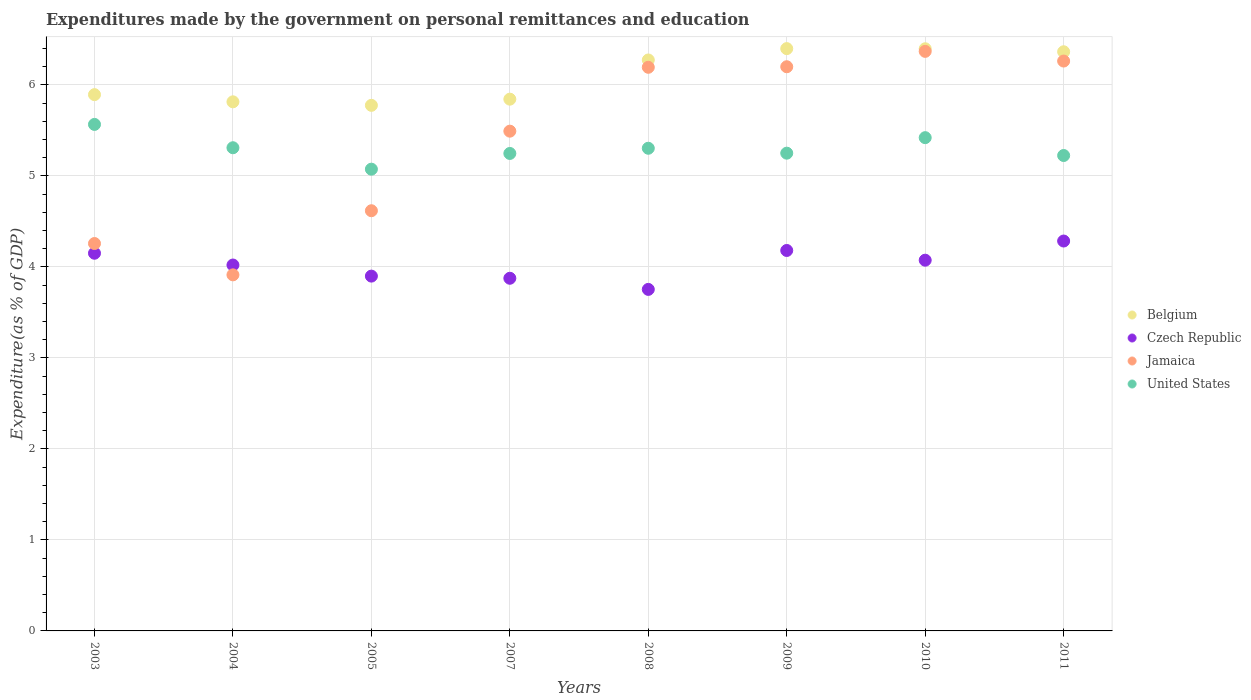How many different coloured dotlines are there?
Provide a succinct answer. 4. What is the expenditures made by the government on personal remittances and education in Belgium in 2004?
Give a very brief answer. 5.81. Across all years, what is the maximum expenditures made by the government on personal remittances and education in United States?
Give a very brief answer. 5.57. Across all years, what is the minimum expenditures made by the government on personal remittances and education in United States?
Provide a succinct answer. 5.07. In which year was the expenditures made by the government on personal remittances and education in United States minimum?
Provide a succinct answer. 2005. What is the total expenditures made by the government on personal remittances and education in Jamaica in the graph?
Offer a terse response. 43.3. What is the difference between the expenditures made by the government on personal remittances and education in Jamaica in 2009 and that in 2010?
Your answer should be very brief. -0.17. What is the difference between the expenditures made by the government on personal remittances and education in Czech Republic in 2010 and the expenditures made by the government on personal remittances and education in Jamaica in 2007?
Provide a succinct answer. -1.42. What is the average expenditures made by the government on personal remittances and education in Czech Republic per year?
Keep it short and to the point. 4.03. In the year 2010, what is the difference between the expenditures made by the government on personal remittances and education in Czech Republic and expenditures made by the government on personal remittances and education in Belgium?
Offer a terse response. -2.32. What is the ratio of the expenditures made by the government on personal remittances and education in Jamaica in 2003 to that in 2010?
Your response must be concise. 0.67. Is the difference between the expenditures made by the government on personal remittances and education in Czech Republic in 2004 and 2011 greater than the difference between the expenditures made by the government on personal remittances and education in Belgium in 2004 and 2011?
Offer a very short reply. Yes. What is the difference between the highest and the second highest expenditures made by the government on personal remittances and education in Jamaica?
Give a very brief answer. 0.11. What is the difference between the highest and the lowest expenditures made by the government on personal remittances and education in United States?
Keep it short and to the point. 0.49. In how many years, is the expenditures made by the government on personal remittances and education in Jamaica greater than the average expenditures made by the government on personal remittances and education in Jamaica taken over all years?
Provide a succinct answer. 5. Is the sum of the expenditures made by the government on personal remittances and education in Belgium in 2007 and 2009 greater than the maximum expenditures made by the government on personal remittances and education in Jamaica across all years?
Your response must be concise. Yes. Does the expenditures made by the government on personal remittances and education in Jamaica monotonically increase over the years?
Your answer should be compact. No. How many years are there in the graph?
Your answer should be very brief. 8. Are the values on the major ticks of Y-axis written in scientific E-notation?
Give a very brief answer. No. Does the graph contain any zero values?
Keep it short and to the point. No. How many legend labels are there?
Your answer should be compact. 4. How are the legend labels stacked?
Give a very brief answer. Vertical. What is the title of the graph?
Ensure brevity in your answer.  Expenditures made by the government on personal remittances and education. What is the label or title of the Y-axis?
Keep it short and to the point. Expenditure(as % of GDP). What is the Expenditure(as % of GDP) of Belgium in 2003?
Your answer should be very brief. 5.89. What is the Expenditure(as % of GDP) of Czech Republic in 2003?
Offer a terse response. 4.15. What is the Expenditure(as % of GDP) of Jamaica in 2003?
Your answer should be very brief. 4.26. What is the Expenditure(as % of GDP) in United States in 2003?
Keep it short and to the point. 5.57. What is the Expenditure(as % of GDP) of Belgium in 2004?
Your answer should be compact. 5.81. What is the Expenditure(as % of GDP) in Czech Republic in 2004?
Ensure brevity in your answer.  4.02. What is the Expenditure(as % of GDP) in Jamaica in 2004?
Give a very brief answer. 3.91. What is the Expenditure(as % of GDP) in United States in 2004?
Keep it short and to the point. 5.31. What is the Expenditure(as % of GDP) in Belgium in 2005?
Provide a short and direct response. 5.78. What is the Expenditure(as % of GDP) of Czech Republic in 2005?
Give a very brief answer. 3.9. What is the Expenditure(as % of GDP) of Jamaica in 2005?
Provide a succinct answer. 4.62. What is the Expenditure(as % of GDP) of United States in 2005?
Keep it short and to the point. 5.07. What is the Expenditure(as % of GDP) of Belgium in 2007?
Your answer should be compact. 5.84. What is the Expenditure(as % of GDP) of Czech Republic in 2007?
Give a very brief answer. 3.88. What is the Expenditure(as % of GDP) in Jamaica in 2007?
Keep it short and to the point. 5.49. What is the Expenditure(as % of GDP) of United States in 2007?
Your answer should be compact. 5.25. What is the Expenditure(as % of GDP) in Belgium in 2008?
Offer a terse response. 6.27. What is the Expenditure(as % of GDP) in Czech Republic in 2008?
Ensure brevity in your answer.  3.75. What is the Expenditure(as % of GDP) in Jamaica in 2008?
Offer a very short reply. 6.19. What is the Expenditure(as % of GDP) of United States in 2008?
Your answer should be very brief. 5.3. What is the Expenditure(as % of GDP) in Belgium in 2009?
Your answer should be very brief. 6.4. What is the Expenditure(as % of GDP) of Czech Republic in 2009?
Your answer should be very brief. 4.18. What is the Expenditure(as % of GDP) of Jamaica in 2009?
Your answer should be compact. 6.2. What is the Expenditure(as % of GDP) in United States in 2009?
Offer a very short reply. 5.25. What is the Expenditure(as % of GDP) in Belgium in 2010?
Provide a succinct answer. 6.4. What is the Expenditure(as % of GDP) of Czech Republic in 2010?
Your answer should be very brief. 4.07. What is the Expenditure(as % of GDP) of Jamaica in 2010?
Your answer should be compact. 6.37. What is the Expenditure(as % of GDP) in United States in 2010?
Keep it short and to the point. 5.42. What is the Expenditure(as % of GDP) of Belgium in 2011?
Your response must be concise. 6.36. What is the Expenditure(as % of GDP) in Czech Republic in 2011?
Keep it short and to the point. 4.28. What is the Expenditure(as % of GDP) of Jamaica in 2011?
Your response must be concise. 6.26. What is the Expenditure(as % of GDP) in United States in 2011?
Your answer should be compact. 5.22. Across all years, what is the maximum Expenditure(as % of GDP) in Belgium?
Ensure brevity in your answer.  6.4. Across all years, what is the maximum Expenditure(as % of GDP) of Czech Republic?
Offer a terse response. 4.28. Across all years, what is the maximum Expenditure(as % of GDP) in Jamaica?
Make the answer very short. 6.37. Across all years, what is the maximum Expenditure(as % of GDP) in United States?
Your answer should be very brief. 5.57. Across all years, what is the minimum Expenditure(as % of GDP) in Belgium?
Provide a succinct answer. 5.78. Across all years, what is the minimum Expenditure(as % of GDP) in Czech Republic?
Your answer should be very brief. 3.75. Across all years, what is the minimum Expenditure(as % of GDP) in Jamaica?
Your answer should be compact. 3.91. Across all years, what is the minimum Expenditure(as % of GDP) of United States?
Ensure brevity in your answer.  5.07. What is the total Expenditure(as % of GDP) of Belgium in the graph?
Offer a terse response. 48.76. What is the total Expenditure(as % of GDP) in Czech Republic in the graph?
Give a very brief answer. 32.24. What is the total Expenditure(as % of GDP) of Jamaica in the graph?
Offer a terse response. 43.3. What is the total Expenditure(as % of GDP) in United States in the graph?
Offer a terse response. 42.39. What is the difference between the Expenditure(as % of GDP) in Belgium in 2003 and that in 2004?
Keep it short and to the point. 0.08. What is the difference between the Expenditure(as % of GDP) of Czech Republic in 2003 and that in 2004?
Give a very brief answer. 0.13. What is the difference between the Expenditure(as % of GDP) in Jamaica in 2003 and that in 2004?
Give a very brief answer. 0.34. What is the difference between the Expenditure(as % of GDP) in United States in 2003 and that in 2004?
Provide a succinct answer. 0.26. What is the difference between the Expenditure(as % of GDP) in Belgium in 2003 and that in 2005?
Provide a succinct answer. 0.12. What is the difference between the Expenditure(as % of GDP) of Czech Republic in 2003 and that in 2005?
Your answer should be compact. 0.25. What is the difference between the Expenditure(as % of GDP) in Jamaica in 2003 and that in 2005?
Offer a very short reply. -0.36. What is the difference between the Expenditure(as % of GDP) of United States in 2003 and that in 2005?
Keep it short and to the point. 0.49. What is the difference between the Expenditure(as % of GDP) in Belgium in 2003 and that in 2007?
Keep it short and to the point. 0.05. What is the difference between the Expenditure(as % of GDP) of Czech Republic in 2003 and that in 2007?
Offer a very short reply. 0.28. What is the difference between the Expenditure(as % of GDP) in Jamaica in 2003 and that in 2007?
Provide a short and direct response. -1.23. What is the difference between the Expenditure(as % of GDP) of United States in 2003 and that in 2007?
Provide a succinct answer. 0.32. What is the difference between the Expenditure(as % of GDP) of Belgium in 2003 and that in 2008?
Give a very brief answer. -0.38. What is the difference between the Expenditure(as % of GDP) in Czech Republic in 2003 and that in 2008?
Make the answer very short. 0.4. What is the difference between the Expenditure(as % of GDP) in Jamaica in 2003 and that in 2008?
Provide a succinct answer. -1.94. What is the difference between the Expenditure(as % of GDP) of United States in 2003 and that in 2008?
Provide a short and direct response. 0.26. What is the difference between the Expenditure(as % of GDP) in Belgium in 2003 and that in 2009?
Your answer should be very brief. -0.51. What is the difference between the Expenditure(as % of GDP) of Czech Republic in 2003 and that in 2009?
Make the answer very short. -0.03. What is the difference between the Expenditure(as % of GDP) of Jamaica in 2003 and that in 2009?
Offer a very short reply. -1.94. What is the difference between the Expenditure(as % of GDP) in United States in 2003 and that in 2009?
Offer a terse response. 0.32. What is the difference between the Expenditure(as % of GDP) in Belgium in 2003 and that in 2010?
Provide a succinct answer. -0.5. What is the difference between the Expenditure(as % of GDP) of Czech Republic in 2003 and that in 2010?
Give a very brief answer. 0.08. What is the difference between the Expenditure(as % of GDP) of Jamaica in 2003 and that in 2010?
Your answer should be compact. -2.11. What is the difference between the Expenditure(as % of GDP) in United States in 2003 and that in 2010?
Keep it short and to the point. 0.15. What is the difference between the Expenditure(as % of GDP) of Belgium in 2003 and that in 2011?
Provide a short and direct response. -0.47. What is the difference between the Expenditure(as % of GDP) in Czech Republic in 2003 and that in 2011?
Ensure brevity in your answer.  -0.13. What is the difference between the Expenditure(as % of GDP) in Jamaica in 2003 and that in 2011?
Your answer should be compact. -2. What is the difference between the Expenditure(as % of GDP) in United States in 2003 and that in 2011?
Ensure brevity in your answer.  0.34. What is the difference between the Expenditure(as % of GDP) in Belgium in 2004 and that in 2005?
Provide a succinct answer. 0.04. What is the difference between the Expenditure(as % of GDP) of Czech Republic in 2004 and that in 2005?
Keep it short and to the point. 0.12. What is the difference between the Expenditure(as % of GDP) of Jamaica in 2004 and that in 2005?
Make the answer very short. -0.7. What is the difference between the Expenditure(as % of GDP) in United States in 2004 and that in 2005?
Your response must be concise. 0.24. What is the difference between the Expenditure(as % of GDP) of Belgium in 2004 and that in 2007?
Provide a succinct answer. -0.03. What is the difference between the Expenditure(as % of GDP) in Czech Republic in 2004 and that in 2007?
Offer a terse response. 0.15. What is the difference between the Expenditure(as % of GDP) in Jamaica in 2004 and that in 2007?
Keep it short and to the point. -1.58. What is the difference between the Expenditure(as % of GDP) in United States in 2004 and that in 2007?
Your response must be concise. 0.06. What is the difference between the Expenditure(as % of GDP) of Belgium in 2004 and that in 2008?
Your answer should be compact. -0.46. What is the difference between the Expenditure(as % of GDP) in Czech Republic in 2004 and that in 2008?
Keep it short and to the point. 0.27. What is the difference between the Expenditure(as % of GDP) of Jamaica in 2004 and that in 2008?
Make the answer very short. -2.28. What is the difference between the Expenditure(as % of GDP) in United States in 2004 and that in 2008?
Provide a short and direct response. 0.01. What is the difference between the Expenditure(as % of GDP) of Belgium in 2004 and that in 2009?
Your response must be concise. -0.58. What is the difference between the Expenditure(as % of GDP) of Czech Republic in 2004 and that in 2009?
Your answer should be very brief. -0.16. What is the difference between the Expenditure(as % of GDP) in Jamaica in 2004 and that in 2009?
Ensure brevity in your answer.  -2.29. What is the difference between the Expenditure(as % of GDP) in United States in 2004 and that in 2009?
Provide a succinct answer. 0.06. What is the difference between the Expenditure(as % of GDP) in Belgium in 2004 and that in 2010?
Give a very brief answer. -0.58. What is the difference between the Expenditure(as % of GDP) of Czech Republic in 2004 and that in 2010?
Your answer should be very brief. -0.05. What is the difference between the Expenditure(as % of GDP) of Jamaica in 2004 and that in 2010?
Offer a terse response. -2.46. What is the difference between the Expenditure(as % of GDP) of United States in 2004 and that in 2010?
Offer a very short reply. -0.11. What is the difference between the Expenditure(as % of GDP) of Belgium in 2004 and that in 2011?
Offer a terse response. -0.55. What is the difference between the Expenditure(as % of GDP) of Czech Republic in 2004 and that in 2011?
Offer a terse response. -0.26. What is the difference between the Expenditure(as % of GDP) in Jamaica in 2004 and that in 2011?
Make the answer very short. -2.35. What is the difference between the Expenditure(as % of GDP) in United States in 2004 and that in 2011?
Give a very brief answer. 0.09. What is the difference between the Expenditure(as % of GDP) in Belgium in 2005 and that in 2007?
Keep it short and to the point. -0.07. What is the difference between the Expenditure(as % of GDP) of Czech Republic in 2005 and that in 2007?
Offer a very short reply. 0.02. What is the difference between the Expenditure(as % of GDP) in Jamaica in 2005 and that in 2007?
Provide a succinct answer. -0.87. What is the difference between the Expenditure(as % of GDP) in United States in 2005 and that in 2007?
Provide a short and direct response. -0.17. What is the difference between the Expenditure(as % of GDP) in Belgium in 2005 and that in 2008?
Ensure brevity in your answer.  -0.5. What is the difference between the Expenditure(as % of GDP) of Czech Republic in 2005 and that in 2008?
Give a very brief answer. 0.15. What is the difference between the Expenditure(as % of GDP) of Jamaica in 2005 and that in 2008?
Provide a succinct answer. -1.58. What is the difference between the Expenditure(as % of GDP) of United States in 2005 and that in 2008?
Keep it short and to the point. -0.23. What is the difference between the Expenditure(as % of GDP) in Belgium in 2005 and that in 2009?
Provide a short and direct response. -0.62. What is the difference between the Expenditure(as % of GDP) in Czech Republic in 2005 and that in 2009?
Provide a short and direct response. -0.28. What is the difference between the Expenditure(as % of GDP) in Jamaica in 2005 and that in 2009?
Provide a succinct answer. -1.58. What is the difference between the Expenditure(as % of GDP) in United States in 2005 and that in 2009?
Your answer should be compact. -0.18. What is the difference between the Expenditure(as % of GDP) of Belgium in 2005 and that in 2010?
Your answer should be compact. -0.62. What is the difference between the Expenditure(as % of GDP) in Czech Republic in 2005 and that in 2010?
Keep it short and to the point. -0.17. What is the difference between the Expenditure(as % of GDP) of Jamaica in 2005 and that in 2010?
Keep it short and to the point. -1.75. What is the difference between the Expenditure(as % of GDP) of United States in 2005 and that in 2010?
Provide a short and direct response. -0.35. What is the difference between the Expenditure(as % of GDP) of Belgium in 2005 and that in 2011?
Offer a terse response. -0.59. What is the difference between the Expenditure(as % of GDP) in Czech Republic in 2005 and that in 2011?
Offer a very short reply. -0.39. What is the difference between the Expenditure(as % of GDP) of Jamaica in 2005 and that in 2011?
Your answer should be very brief. -1.64. What is the difference between the Expenditure(as % of GDP) in United States in 2005 and that in 2011?
Your response must be concise. -0.15. What is the difference between the Expenditure(as % of GDP) in Belgium in 2007 and that in 2008?
Ensure brevity in your answer.  -0.43. What is the difference between the Expenditure(as % of GDP) of Czech Republic in 2007 and that in 2008?
Your answer should be very brief. 0.12. What is the difference between the Expenditure(as % of GDP) of Jamaica in 2007 and that in 2008?
Your answer should be compact. -0.7. What is the difference between the Expenditure(as % of GDP) of United States in 2007 and that in 2008?
Your answer should be compact. -0.06. What is the difference between the Expenditure(as % of GDP) in Belgium in 2007 and that in 2009?
Offer a terse response. -0.56. What is the difference between the Expenditure(as % of GDP) of Czech Republic in 2007 and that in 2009?
Make the answer very short. -0.31. What is the difference between the Expenditure(as % of GDP) of Jamaica in 2007 and that in 2009?
Your response must be concise. -0.71. What is the difference between the Expenditure(as % of GDP) in United States in 2007 and that in 2009?
Offer a terse response. -0. What is the difference between the Expenditure(as % of GDP) of Belgium in 2007 and that in 2010?
Offer a terse response. -0.55. What is the difference between the Expenditure(as % of GDP) of Czech Republic in 2007 and that in 2010?
Provide a short and direct response. -0.2. What is the difference between the Expenditure(as % of GDP) in Jamaica in 2007 and that in 2010?
Give a very brief answer. -0.88. What is the difference between the Expenditure(as % of GDP) of United States in 2007 and that in 2010?
Ensure brevity in your answer.  -0.17. What is the difference between the Expenditure(as % of GDP) of Belgium in 2007 and that in 2011?
Your answer should be compact. -0.52. What is the difference between the Expenditure(as % of GDP) in Czech Republic in 2007 and that in 2011?
Offer a very short reply. -0.41. What is the difference between the Expenditure(as % of GDP) of Jamaica in 2007 and that in 2011?
Your answer should be very brief. -0.77. What is the difference between the Expenditure(as % of GDP) of United States in 2007 and that in 2011?
Keep it short and to the point. 0.02. What is the difference between the Expenditure(as % of GDP) of Belgium in 2008 and that in 2009?
Your answer should be compact. -0.12. What is the difference between the Expenditure(as % of GDP) of Czech Republic in 2008 and that in 2009?
Offer a terse response. -0.43. What is the difference between the Expenditure(as % of GDP) of Jamaica in 2008 and that in 2009?
Ensure brevity in your answer.  -0.01. What is the difference between the Expenditure(as % of GDP) of United States in 2008 and that in 2009?
Offer a very short reply. 0.05. What is the difference between the Expenditure(as % of GDP) of Belgium in 2008 and that in 2010?
Make the answer very short. -0.12. What is the difference between the Expenditure(as % of GDP) in Czech Republic in 2008 and that in 2010?
Your response must be concise. -0.32. What is the difference between the Expenditure(as % of GDP) in Jamaica in 2008 and that in 2010?
Your answer should be compact. -0.17. What is the difference between the Expenditure(as % of GDP) in United States in 2008 and that in 2010?
Make the answer very short. -0.12. What is the difference between the Expenditure(as % of GDP) in Belgium in 2008 and that in 2011?
Give a very brief answer. -0.09. What is the difference between the Expenditure(as % of GDP) in Czech Republic in 2008 and that in 2011?
Your response must be concise. -0.53. What is the difference between the Expenditure(as % of GDP) of Jamaica in 2008 and that in 2011?
Your answer should be compact. -0.07. What is the difference between the Expenditure(as % of GDP) in United States in 2008 and that in 2011?
Offer a terse response. 0.08. What is the difference between the Expenditure(as % of GDP) in Belgium in 2009 and that in 2010?
Offer a very short reply. 0. What is the difference between the Expenditure(as % of GDP) of Czech Republic in 2009 and that in 2010?
Offer a terse response. 0.11. What is the difference between the Expenditure(as % of GDP) in Jamaica in 2009 and that in 2010?
Give a very brief answer. -0.17. What is the difference between the Expenditure(as % of GDP) of United States in 2009 and that in 2010?
Your response must be concise. -0.17. What is the difference between the Expenditure(as % of GDP) of Belgium in 2009 and that in 2011?
Your answer should be compact. 0.03. What is the difference between the Expenditure(as % of GDP) in Czech Republic in 2009 and that in 2011?
Offer a terse response. -0.1. What is the difference between the Expenditure(as % of GDP) in Jamaica in 2009 and that in 2011?
Keep it short and to the point. -0.06. What is the difference between the Expenditure(as % of GDP) in United States in 2009 and that in 2011?
Your answer should be very brief. 0.03. What is the difference between the Expenditure(as % of GDP) in Belgium in 2010 and that in 2011?
Give a very brief answer. 0.03. What is the difference between the Expenditure(as % of GDP) in Czech Republic in 2010 and that in 2011?
Provide a short and direct response. -0.21. What is the difference between the Expenditure(as % of GDP) of Jamaica in 2010 and that in 2011?
Provide a short and direct response. 0.11. What is the difference between the Expenditure(as % of GDP) in United States in 2010 and that in 2011?
Your response must be concise. 0.2. What is the difference between the Expenditure(as % of GDP) in Belgium in 2003 and the Expenditure(as % of GDP) in Czech Republic in 2004?
Make the answer very short. 1.87. What is the difference between the Expenditure(as % of GDP) in Belgium in 2003 and the Expenditure(as % of GDP) in Jamaica in 2004?
Keep it short and to the point. 1.98. What is the difference between the Expenditure(as % of GDP) in Belgium in 2003 and the Expenditure(as % of GDP) in United States in 2004?
Your response must be concise. 0.58. What is the difference between the Expenditure(as % of GDP) in Czech Republic in 2003 and the Expenditure(as % of GDP) in Jamaica in 2004?
Your answer should be very brief. 0.24. What is the difference between the Expenditure(as % of GDP) in Czech Republic in 2003 and the Expenditure(as % of GDP) in United States in 2004?
Ensure brevity in your answer.  -1.16. What is the difference between the Expenditure(as % of GDP) of Jamaica in 2003 and the Expenditure(as % of GDP) of United States in 2004?
Your response must be concise. -1.05. What is the difference between the Expenditure(as % of GDP) in Belgium in 2003 and the Expenditure(as % of GDP) in Czech Republic in 2005?
Your answer should be very brief. 1.99. What is the difference between the Expenditure(as % of GDP) in Belgium in 2003 and the Expenditure(as % of GDP) in Jamaica in 2005?
Provide a short and direct response. 1.28. What is the difference between the Expenditure(as % of GDP) in Belgium in 2003 and the Expenditure(as % of GDP) in United States in 2005?
Your response must be concise. 0.82. What is the difference between the Expenditure(as % of GDP) of Czech Republic in 2003 and the Expenditure(as % of GDP) of Jamaica in 2005?
Provide a succinct answer. -0.47. What is the difference between the Expenditure(as % of GDP) of Czech Republic in 2003 and the Expenditure(as % of GDP) of United States in 2005?
Make the answer very short. -0.92. What is the difference between the Expenditure(as % of GDP) in Jamaica in 2003 and the Expenditure(as % of GDP) in United States in 2005?
Keep it short and to the point. -0.82. What is the difference between the Expenditure(as % of GDP) in Belgium in 2003 and the Expenditure(as % of GDP) in Czech Republic in 2007?
Your response must be concise. 2.02. What is the difference between the Expenditure(as % of GDP) of Belgium in 2003 and the Expenditure(as % of GDP) of Jamaica in 2007?
Keep it short and to the point. 0.4. What is the difference between the Expenditure(as % of GDP) of Belgium in 2003 and the Expenditure(as % of GDP) of United States in 2007?
Offer a very short reply. 0.65. What is the difference between the Expenditure(as % of GDP) of Czech Republic in 2003 and the Expenditure(as % of GDP) of Jamaica in 2007?
Your response must be concise. -1.34. What is the difference between the Expenditure(as % of GDP) of Czech Republic in 2003 and the Expenditure(as % of GDP) of United States in 2007?
Your answer should be very brief. -1.1. What is the difference between the Expenditure(as % of GDP) of Jamaica in 2003 and the Expenditure(as % of GDP) of United States in 2007?
Keep it short and to the point. -0.99. What is the difference between the Expenditure(as % of GDP) of Belgium in 2003 and the Expenditure(as % of GDP) of Czech Republic in 2008?
Your answer should be compact. 2.14. What is the difference between the Expenditure(as % of GDP) in Belgium in 2003 and the Expenditure(as % of GDP) in Jamaica in 2008?
Your answer should be very brief. -0.3. What is the difference between the Expenditure(as % of GDP) in Belgium in 2003 and the Expenditure(as % of GDP) in United States in 2008?
Provide a short and direct response. 0.59. What is the difference between the Expenditure(as % of GDP) in Czech Republic in 2003 and the Expenditure(as % of GDP) in Jamaica in 2008?
Provide a short and direct response. -2.04. What is the difference between the Expenditure(as % of GDP) of Czech Republic in 2003 and the Expenditure(as % of GDP) of United States in 2008?
Offer a terse response. -1.15. What is the difference between the Expenditure(as % of GDP) of Jamaica in 2003 and the Expenditure(as % of GDP) of United States in 2008?
Keep it short and to the point. -1.05. What is the difference between the Expenditure(as % of GDP) in Belgium in 2003 and the Expenditure(as % of GDP) in Czech Republic in 2009?
Provide a short and direct response. 1.71. What is the difference between the Expenditure(as % of GDP) in Belgium in 2003 and the Expenditure(as % of GDP) in Jamaica in 2009?
Provide a succinct answer. -0.31. What is the difference between the Expenditure(as % of GDP) of Belgium in 2003 and the Expenditure(as % of GDP) of United States in 2009?
Make the answer very short. 0.64. What is the difference between the Expenditure(as % of GDP) in Czech Republic in 2003 and the Expenditure(as % of GDP) in Jamaica in 2009?
Your response must be concise. -2.05. What is the difference between the Expenditure(as % of GDP) of Czech Republic in 2003 and the Expenditure(as % of GDP) of United States in 2009?
Provide a succinct answer. -1.1. What is the difference between the Expenditure(as % of GDP) of Jamaica in 2003 and the Expenditure(as % of GDP) of United States in 2009?
Keep it short and to the point. -0.99. What is the difference between the Expenditure(as % of GDP) of Belgium in 2003 and the Expenditure(as % of GDP) of Czech Republic in 2010?
Your answer should be compact. 1.82. What is the difference between the Expenditure(as % of GDP) of Belgium in 2003 and the Expenditure(as % of GDP) of Jamaica in 2010?
Your answer should be compact. -0.48. What is the difference between the Expenditure(as % of GDP) in Belgium in 2003 and the Expenditure(as % of GDP) in United States in 2010?
Provide a short and direct response. 0.47. What is the difference between the Expenditure(as % of GDP) in Czech Republic in 2003 and the Expenditure(as % of GDP) in Jamaica in 2010?
Offer a terse response. -2.22. What is the difference between the Expenditure(as % of GDP) of Czech Republic in 2003 and the Expenditure(as % of GDP) of United States in 2010?
Give a very brief answer. -1.27. What is the difference between the Expenditure(as % of GDP) in Jamaica in 2003 and the Expenditure(as % of GDP) in United States in 2010?
Your answer should be compact. -1.16. What is the difference between the Expenditure(as % of GDP) of Belgium in 2003 and the Expenditure(as % of GDP) of Czech Republic in 2011?
Your answer should be very brief. 1.61. What is the difference between the Expenditure(as % of GDP) of Belgium in 2003 and the Expenditure(as % of GDP) of Jamaica in 2011?
Keep it short and to the point. -0.37. What is the difference between the Expenditure(as % of GDP) of Belgium in 2003 and the Expenditure(as % of GDP) of United States in 2011?
Keep it short and to the point. 0.67. What is the difference between the Expenditure(as % of GDP) in Czech Republic in 2003 and the Expenditure(as % of GDP) in Jamaica in 2011?
Ensure brevity in your answer.  -2.11. What is the difference between the Expenditure(as % of GDP) of Czech Republic in 2003 and the Expenditure(as % of GDP) of United States in 2011?
Your response must be concise. -1.07. What is the difference between the Expenditure(as % of GDP) of Jamaica in 2003 and the Expenditure(as % of GDP) of United States in 2011?
Your answer should be compact. -0.97. What is the difference between the Expenditure(as % of GDP) in Belgium in 2004 and the Expenditure(as % of GDP) in Czech Republic in 2005?
Ensure brevity in your answer.  1.92. What is the difference between the Expenditure(as % of GDP) in Belgium in 2004 and the Expenditure(as % of GDP) in Jamaica in 2005?
Give a very brief answer. 1.2. What is the difference between the Expenditure(as % of GDP) of Belgium in 2004 and the Expenditure(as % of GDP) of United States in 2005?
Provide a succinct answer. 0.74. What is the difference between the Expenditure(as % of GDP) of Czech Republic in 2004 and the Expenditure(as % of GDP) of Jamaica in 2005?
Ensure brevity in your answer.  -0.6. What is the difference between the Expenditure(as % of GDP) of Czech Republic in 2004 and the Expenditure(as % of GDP) of United States in 2005?
Your answer should be compact. -1.05. What is the difference between the Expenditure(as % of GDP) in Jamaica in 2004 and the Expenditure(as % of GDP) in United States in 2005?
Offer a very short reply. -1.16. What is the difference between the Expenditure(as % of GDP) in Belgium in 2004 and the Expenditure(as % of GDP) in Czech Republic in 2007?
Offer a very short reply. 1.94. What is the difference between the Expenditure(as % of GDP) of Belgium in 2004 and the Expenditure(as % of GDP) of Jamaica in 2007?
Ensure brevity in your answer.  0.32. What is the difference between the Expenditure(as % of GDP) in Belgium in 2004 and the Expenditure(as % of GDP) in United States in 2007?
Offer a very short reply. 0.57. What is the difference between the Expenditure(as % of GDP) of Czech Republic in 2004 and the Expenditure(as % of GDP) of Jamaica in 2007?
Your answer should be very brief. -1.47. What is the difference between the Expenditure(as % of GDP) in Czech Republic in 2004 and the Expenditure(as % of GDP) in United States in 2007?
Your answer should be very brief. -1.23. What is the difference between the Expenditure(as % of GDP) in Jamaica in 2004 and the Expenditure(as % of GDP) in United States in 2007?
Provide a succinct answer. -1.33. What is the difference between the Expenditure(as % of GDP) in Belgium in 2004 and the Expenditure(as % of GDP) in Czech Republic in 2008?
Make the answer very short. 2.06. What is the difference between the Expenditure(as % of GDP) in Belgium in 2004 and the Expenditure(as % of GDP) in Jamaica in 2008?
Ensure brevity in your answer.  -0.38. What is the difference between the Expenditure(as % of GDP) in Belgium in 2004 and the Expenditure(as % of GDP) in United States in 2008?
Your answer should be very brief. 0.51. What is the difference between the Expenditure(as % of GDP) in Czech Republic in 2004 and the Expenditure(as % of GDP) in Jamaica in 2008?
Provide a short and direct response. -2.17. What is the difference between the Expenditure(as % of GDP) in Czech Republic in 2004 and the Expenditure(as % of GDP) in United States in 2008?
Your answer should be compact. -1.28. What is the difference between the Expenditure(as % of GDP) in Jamaica in 2004 and the Expenditure(as % of GDP) in United States in 2008?
Make the answer very short. -1.39. What is the difference between the Expenditure(as % of GDP) of Belgium in 2004 and the Expenditure(as % of GDP) of Czech Republic in 2009?
Offer a very short reply. 1.63. What is the difference between the Expenditure(as % of GDP) in Belgium in 2004 and the Expenditure(as % of GDP) in Jamaica in 2009?
Keep it short and to the point. -0.39. What is the difference between the Expenditure(as % of GDP) in Belgium in 2004 and the Expenditure(as % of GDP) in United States in 2009?
Offer a terse response. 0.56. What is the difference between the Expenditure(as % of GDP) in Czech Republic in 2004 and the Expenditure(as % of GDP) in Jamaica in 2009?
Offer a terse response. -2.18. What is the difference between the Expenditure(as % of GDP) of Czech Republic in 2004 and the Expenditure(as % of GDP) of United States in 2009?
Offer a terse response. -1.23. What is the difference between the Expenditure(as % of GDP) in Jamaica in 2004 and the Expenditure(as % of GDP) in United States in 2009?
Make the answer very short. -1.34. What is the difference between the Expenditure(as % of GDP) of Belgium in 2004 and the Expenditure(as % of GDP) of Czech Republic in 2010?
Offer a terse response. 1.74. What is the difference between the Expenditure(as % of GDP) in Belgium in 2004 and the Expenditure(as % of GDP) in Jamaica in 2010?
Your response must be concise. -0.55. What is the difference between the Expenditure(as % of GDP) of Belgium in 2004 and the Expenditure(as % of GDP) of United States in 2010?
Ensure brevity in your answer.  0.39. What is the difference between the Expenditure(as % of GDP) in Czech Republic in 2004 and the Expenditure(as % of GDP) in Jamaica in 2010?
Ensure brevity in your answer.  -2.35. What is the difference between the Expenditure(as % of GDP) of Czech Republic in 2004 and the Expenditure(as % of GDP) of United States in 2010?
Offer a very short reply. -1.4. What is the difference between the Expenditure(as % of GDP) of Jamaica in 2004 and the Expenditure(as % of GDP) of United States in 2010?
Keep it short and to the point. -1.51. What is the difference between the Expenditure(as % of GDP) in Belgium in 2004 and the Expenditure(as % of GDP) in Czech Republic in 2011?
Give a very brief answer. 1.53. What is the difference between the Expenditure(as % of GDP) in Belgium in 2004 and the Expenditure(as % of GDP) in Jamaica in 2011?
Give a very brief answer. -0.45. What is the difference between the Expenditure(as % of GDP) in Belgium in 2004 and the Expenditure(as % of GDP) in United States in 2011?
Offer a very short reply. 0.59. What is the difference between the Expenditure(as % of GDP) in Czech Republic in 2004 and the Expenditure(as % of GDP) in Jamaica in 2011?
Give a very brief answer. -2.24. What is the difference between the Expenditure(as % of GDP) of Czech Republic in 2004 and the Expenditure(as % of GDP) of United States in 2011?
Provide a short and direct response. -1.2. What is the difference between the Expenditure(as % of GDP) of Jamaica in 2004 and the Expenditure(as % of GDP) of United States in 2011?
Provide a short and direct response. -1.31. What is the difference between the Expenditure(as % of GDP) of Belgium in 2005 and the Expenditure(as % of GDP) of Czech Republic in 2007?
Make the answer very short. 1.9. What is the difference between the Expenditure(as % of GDP) in Belgium in 2005 and the Expenditure(as % of GDP) in Jamaica in 2007?
Make the answer very short. 0.28. What is the difference between the Expenditure(as % of GDP) in Belgium in 2005 and the Expenditure(as % of GDP) in United States in 2007?
Provide a succinct answer. 0.53. What is the difference between the Expenditure(as % of GDP) of Czech Republic in 2005 and the Expenditure(as % of GDP) of Jamaica in 2007?
Your response must be concise. -1.59. What is the difference between the Expenditure(as % of GDP) in Czech Republic in 2005 and the Expenditure(as % of GDP) in United States in 2007?
Keep it short and to the point. -1.35. What is the difference between the Expenditure(as % of GDP) of Jamaica in 2005 and the Expenditure(as % of GDP) of United States in 2007?
Offer a terse response. -0.63. What is the difference between the Expenditure(as % of GDP) in Belgium in 2005 and the Expenditure(as % of GDP) in Czech Republic in 2008?
Your response must be concise. 2.02. What is the difference between the Expenditure(as % of GDP) in Belgium in 2005 and the Expenditure(as % of GDP) in Jamaica in 2008?
Your answer should be very brief. -0.42. What is the difference between the Expenditure(as % of GDP) in Belgium in 2005 and the Expenditure(as % of GDP) in United States in 2008?
Offer a very short reply. 0.47. What is the difference between the Expenditure(as % of GDP) of Czech Republic in 2005 and the Expenditure(as % of GDP) of Jamaica in 2008?
Ensure brevity in your answer.  -2.29. What is the difference between the Expenditure(as % of GDP) in Czech Republic in 2005 and the Expenditure(as % of GDP) in United States in 2008?
Give a very brief answer. -1.4. What is the difference between the Expenditure(as % of GDP) of Jamaica in 2005 and the Expenditure(as % of GDP) of United States in 2008?
Provide a short and direct response. -0.69. What is the difference between the Expenditure(as % of GDP) of Belgium in 2005 and the Expenditure(as % of GDP) of Czech Republic in 2009?
Your answer should be very brief. 1.59. What is the difference between the Expenditure(as % of GDP) of Belgium in 2005 and the Expenditure(as % of GDP) of Jamaica in 2009?
Your answer should be compact. -0.42. What is the difference between the Expenditure(as % of GDP) of Belgium in 2005 and the Expenditure(as % of GDP) of United States in 2009?
Provide a short and direct response. 0.53. What is the difference between the Expenditure(as % of GDP) of Czech Republic in 2005 and the Expenditure(as % of GDP) of Jamaica in 2009?
Your answer should be compact. -2.3. What is the difference between the Expenditure(as % of GDP) in Czech Republic in 2005 and the Expenditure(as % of GDP) in United States in 2009?
Make the answer very short. -1.35. What is the difference between the Expenditure(as % of GDP) of Jamaica in 2005 and the Expenditure(as % of GDP) of United States in 2009?
Your response must be concise. -0.63. What is the difference between the Expenditure(as % of GDP) of Belgium in 2005 and the Expenditure(as % of GDP) of Czech Republic in 2010?
Your answer should be very brief. 1.7. What is the difference between the Expenditure(as % of GDP) in Belgium in 2005 and the Expenditure(as % of GDP) in Jamaica in 2010?
Your response must be concise. -0.59. What is the difference between the Expenditure(as % of GDP) in Belgium in 2005 and the Expenditure(as % of GDP) in United States in 2010?
Your answer should be very brief. 0.36. What is the difference between the Expenditure(as % of GDP) in Czech Republic in 2005 and the Expenditure(as % of GDP) in Jamaica in 2010?
Offer a very short reply. -2.47. What is the difference between the Expenditure(as % of GDP) in Czech Republic in 2005 and the Expenditure(as % of GDP) in United States in 2010?
Provide a succinct answer. -1.52. What is the difference between the Expenditure(as % of GDP) in Jamaica in 2005 and the Expenditure(as % of GDP) in United States in 2010?
Make the answer very short. -0.8. What is the difference between the Expenditure(as % of GDP) in Belgium in 2005 and the Expenditure(as % of GDP) in Czech Republic in 2011?
Your answer should be compact. 1.49. What is the difference between the Expenditure(as % of GDP) of Belgium in 2005 and the Expenditure(as % of GDP) of Jamaica in 2011?
Give a very brief answer. -0.49. What is the difference between the Expenditure(as % of GDP) of Belgium in 2005 and the Expenditure(as % of GDP) of United States in 2011?
Offer a terse response. 0.55. What is the difference between the Expenditure(as % of GDP) in Czech Republic in 2005 and the Expenditure(as % of GDP) in Jamaica in 2011?
Offer a very short reply. -2.36. What is the difference between the Expenditure(as % of GDP) in Czech Republic in 2005 and the Expenditure(as % of GDP) in United States in 2011?
Offer a very short reply. -1.33. What is the difference between the Expenditure(as % of GDP) of Jamaica in 2005 and the Expenditure(as % of GDP) of United States in 2011?
Provide a succinct answer. -0.61. What is the difference between the Expenditure(as % of GDP) of Belgium in 2007 and the Expenditure(as % of GDP) of Czech Republic in 2008?
Your answer should be very brief. 2.09. What is the difference between the Expenditure(as % of GDP) of Belgium in 2007 and the Expenditure(as % of GDP) of Jamaica in 2008?
Offer a terse response. -0.35. What is the difference between the Expenditure(as % of GDP) in Belgium in 2007 and the Expenditure(as % of GDP) in United States in 2008?
Offer a very short reply. 0.54. What is the difference between the Expenditure(as % of GDP) in Czech Republic in 2007 and the Expenditure(as % of GDP) in Jamaica in 2008?
Your answer should be compact. -2.32. What is the difference between the Expenditure(as % of GDP) in Czech Republic in 2007 and the Expenditure(as % of GDP) in United States in 2008?
Provide a short and direct response. -1.43. What is the difference between the Expenditure(as % of GDP) of Jamaica in 2007 and the Expenditure(as % of GDP) of United States in 2008?
Your answer should be compact. 0.19. What is the difference between the Expenditure(as % of GDP) in Belgium in 2007 and the Expenditure(as % of GDP) in Czech Republic in 2009?
Your response must be concise. 1.66. What is the difference between the Expenditure(as % of GDP) of Belgium in 2007 and the Expenditure(as % of GDP) of Jamaica in 2009?
Offer a terse response. -0.36. What is the difference between the Expenditure(as % of GDP) in Belgium in 2007 and the Expenditure(as % of GDP) in United States in 2009?
Make the answer very short. 0.59. What is the difference between the Expenditure(as % of GDP) in Czech Republic in 2007 and the Expenditure(as % of GDP) in Jamaica in 2009?
Your response must be concise. -2.32. What is the difference between the Expenditure(as % of GDP) of Czech Republic in 2007 and the Expenditure(as % of GDP) of United States in 2009?
Your answer should be compact. -1.37. What is the difference between the Expenditure(as % of GDP) in Jamaica in 2007 and the Expenditure(as % of GDP) in United States in 2009?
Offer a very short reply. 0.24. What is the difference between the Expenditure(as % of GDP) in Belgium in 2007 and the Expenditure(as % of GDP) in Czech Republic in 2010?
Your answer should be compact. 1.77. What is the difference between the Expenditure(as % of GDP) in Belgium in 2007 and the Expenditure(as % of GDP) in Jamaica in 2010?
Keep it short and to the point. -0.53. What is the difference between the Expenditure(as % of GDP) of Belgium in 2007 and the Expenditure(as % of GDP) of United States in 2010?
Offer a very short reply. 0.42. What is the difference between the Expenditure(as % of GDP) of Czech Republic in 2007 and the Expenditure(as % of GDP) of Jamaica in 2010?
Keep it short and to the point. -2.49. What is the difference between the Expenditure(as % of GDP) in Czech Republic in 2007 and the Expenditure(as % of GDP) in United States in 2010?
Provide a short and direct response. -1.54. What is the difference between the Expenditure(as % of GDP) of Jamaica in 2007 and the Expenditure(as % of GDP) of United States in 2010?
Your answer should be very brief. 0.07. What is the difference between the Expenditure(as % of GDP) of Belgium in 2007 and the Expenditure(as % of GDP) of Czech Republic in 2011?
Your answer should be very brief. 1.56. What is the difference between the Expenditure(as % of GDP) in Belgium in 2007 and the Expenditure(as % of GDP) in Jamaica in 2011?
Make the answer very short. -0.42. What is the difference between the Expenditure(as % of GDP) in Belgium in 2007 and the Expenditure(as % of GDP) in United States in 2011?
Ensure brevity in your answer.  0.62. What is the difference between the Expenditure(as % of GDP) of Czech Republic in 2007 and the Expenditure(as % of GDP) of Jamaica in 2011?
Offer a very short reply. -2.39. What is the difference between the Expenditure(as % of GDP) of Czech Republic in 2007 and the Expenditure(as % of GDP) of United States in 2011?
Give a very brief answer. -1.35. What is the difference between the Expenditure(as % of GDP) of Jamaica in 2007 and the Expenditure(as % of GDP) of United States in 2011?
Make the answer very short. 0.27. What is the difference between the Expenditure(as % of GDP) of Belgium in 2008 and the Expenditure(as % of GDP) of Czech Republic in 2009?
Ensure brevity in your answer.  2.09. What is the difference between the Expenditure(as % of GDP) of Belgium in 2008 and the Expenditure(as % of GDP) of Jamaica in 2009?
Ensure brevity in your answer.  0.07. What is the difference between the Expenditure(as % of GDP) of Belgium in 2008 and the Expenditure(as % of GDP) of United States in 2009?
Your answer should be very brief. 1.02. What is the difference between the Expenditure(as % of GDP) of Czech Republic in 2008 and the Expenditure(as % of GDP) of Jamaica in 2009?
Offer a terse response. -2.45. What is the difference between the Expenditure(as % of GDP) of Czech Republic in 2008 and the Expenditure(as % of GDP) of United States in 2009?
Your response must be concise. -1.5. What is the difference between the Expenditure(as % of GDP) in Jamaica in 2008 and the Expenditure(as % of GDP) in United States in 2009?
Provide a short and direct response. 0.94. What is the difference between the Expenditure(as % of GDP) of Belgium in 2008 and the Expenditure(as % of GDP) of Czech Republic in 2010?
Make the answer very short. 2.2. What is the difference between the Expenditure(as % of GDP) of Belgium in 2008 and the Expenditure(as % of GDP) of Jamaica in 2010?
Your answer should be compact. -0.09. What is the difference between the Expenditure(as % of GDP) of Belgium in 2008 and the Expenditure(as % of GDP) of United States in 2010?
Make the answer very short. 0.85. What is the difference between the Expenditure(as % of GDP) in Czech Republic in 2008 and the Expenditure(as % of GDP) in Jamaica in 2010?
Provide a succinct answer. -2.62. What is the difference between the Expenditure(as % of GDP) in Czech Republic in 2008 and the Expenditure(as % of GDP) in United States in 2010?
Ensure brevity in your answer.  -1.67. What is the difference between the Expenditure(as % of GDP) in Jamaica in 2008 and the Expenditure(as % of GDP) in United States in 2010?
Your answer should be compact. 0.77. What is the difference between the Expenditure(as % of GDP) of Belgium in 2008 and the Expenditure(as % of GDP) of Czech Republic in 2011?
Provide a succinct answer. 1.99. What is the difference between the Expenditure(as % of GDP) in Belgium in 2008 and the Expenditure(as % of GDP) in Jamaica in 2011?
Offer a terse response. 0.01. What is the difference between the Expenditure(as % of GDP) of Belgium in 2008 and the Expenditure(as % of GDP) of United States in 2011?
Ensure brevity in your answer.  1.05. What is the difference between the Expenditure(as % of GDP) in Czech Republic in 2008 and the Expenditure(as % of GDP) in Jamaica in 2011?
Give a very brief answer. -2.51. What is the difference between the Expenditure(as % of GDP) of Czech Republic in 2008 and the Expenditure(as % of GDP) of United States in 2011?
Your response must be concise. -1.47. What is the difference between the Expenditure(as % of GDP) in Jamaica in 2008 and the Expenditure(as % of GDP) in United States in 2011?
Provide a short and direct response. 0.97. What is the difference between the Expenditure(as % of GDP) of Belgium in 2009 and the Expenditure(as % of GDP) of Czech Republic in 2010?
Your answer should be compact. 2.32. What is the difference between the Expenditure(as % of GDP) in Belgium in 2009 and the Expenditure(as % of GDP) in Jamaica in 2010?
Your answer should be compact. 0.03. What is the difference between the Expenditure(as % of GDP) in Belgium in 2009 and the Expenditure(as % of GDP) in United States in 2010?
Give a very brief answer. 0.98. What is the difference between the Expenditure(as % of GDP) of Czech Republic in 2009 and the Expenditure(as % of GDP) of Jamaica in 2010?
Keep it short and to the point. -2.19. What is the difference between the Expenditure(as % of GDP) in Czech Republic in 2009 and the Expenditure(as % of GDP) in United States in 2010?
Offer a terse response. -1.24. What is the difference between the Expenditure(as % of GDP) of Jamaica in 2009 and the Expenditure(as % of GDP) of United States in 2010?
Provide a succinct answer. 0.78. What is the difference between the Expenditure(as % of GDP) of Belgium in 2009 and the Expenditure(as % of GDP) of Czech Republic in 2011?
Give a very brief answer. 2.11. What is the difference between the Expenditure(as % of GDP) in Belgium in 2009 and the Expenditure(as % of GDP) in Jamaica in 2011?
Make the answer very short. 0.14. What is the difference between the Expenditure(as % of GDP) of Belgium in 2009 and the Expenditure(as % of GDP) of United States in 2011?
Provide a succinct answer. 1.17. What is the difference between the Expenditure(as % of GDP) of Czech Republic in 2009 and the Expenditure(as % of GDP) of Jamaica in 2011?
Ensure brevity in your answer.  -2.08. What is the difference between the Expenditure(as % of GDP) in Czech Republic in 2009 and the Expenditure(as % of GDP) in United States in 2011?
Your response must be concise. -1.04. What is the difference between the Expenditure(as % of GDP) of Jamaica in 2009 and the Expenditure(as % of GDP) of United States in 2011?
Your answer should be very brief. 0.98. What is the difference between the Expenditure(as % of GDP) in Belgium in 2010 and the Expenditure(as % of GDP) in Czech Republic in 2011?
Your answer should be very brief. 2.11. What is the difference between the Expenditure(as % of GDP) of Belgium in 2010 and the Expenditure(as % of GDP) of Jamaica in 2011?
Your answer should be very brief. 0.13. What is the difference between the Expenditure(as % of GDP) in Belgium in 2010 and the Expenditure(as % of GDP) in United States in 2011?
Your answer should be very brief. 1.17. What is the difference between the Expenditure(as % of GDP) in Czech Republic in 2010 and the Expenditure(as % of GDP) in Jamaica in 2011?
Your answer should be compact. -2.19. What is the difference between the Expenditure(as % of GDP) of Czech Republic in 2010 and the Expenditure(as % of GDP) of United States in 2011?
Make the answer very short. -1.15. What is the difference between the Expenditure(as % of GDP) of Jamaica in 2010 and the Expenditure(as % of GDP) of United States in 2011?
Make the answer very short. 1.14. What is the average Expenditure(as % of GDP) of Belgium per year?
Your answer should be very brief. 6.09. What is the average Expenditure(as % of GDP) in Czech Republic per year?
Give a very brief answer. 4.03. What is the average Expenditure(as % of GDP) of Jamaica per year?
Ensure brevity in your answer.  5.41. What is the average Expenditure(as % of GDP) of United States per year?
Keep it short and to the point. 5.3. In the year 2003, what is the difference between the Expenditure(as % of GDP) of Belgium and Expenditure(as % of GDP) of Czech Republic?
Keep it short and to the point. 1.74. In the year 2003, what is the difference between the Expenditure(as % of GDP) in Belgium and Expenditure(as % of GDP) in Jamaica?
Offer a very short reply. 1.64. In the year 2003, what is the difference between the Expenditure(as % of GDP) of Belgium and Expenditure(as % of GDP) of United States?
Provide a succinct answer. 0.33. In the year 2003, what is the difference between the Expenditure(as % of GDP) of Czech Republic and Expenditure(as % of GDP) of Jamaica?
Your answer should be very brief. -0.11. In the year 2003, what is the difference between the Expenditure(as % of GDP) of Czech Republic and Expenditure(as % of GDP) of United States?
Provide a short and direct response. -1.42. In the year 2003, what is the difference between the Expenditure(as % of GDP) in Jamaica and Expenditure(as % of GDP) in United States?
Offer a very short reply. -1.31. In the year 2004, what is the difference between the Expenditure(as % of GDP) in Belgium and Expenditure(as % of GDP) in Czech Republic?
Your answer should be compact. 1.79. In the year 2004, what is the difference between the Expenditure(as % of GDP) in Belgium and Expenditure(as % of GDP) in Jamaica?
Give a very brief answer. 1.9. In the year 2004, what is the difference between the Expenditure(as % of GDP) of Belgium and Expenditure(as % of GDP) of United States?
Your answer should be compact. 0.5. In the year 2004, what is the difference between the Expenditure(as % of GDP) of Czech Republic and Expenditure(as % of GDP) of Jamaica?
Make the answer very short. 0.11. In the year 2004, what is the difference between the Expenditure(as % of GDP) of Czech Republic and Expenditure(as % of GDP) of United States?
Your answer should be very brief. -1.29. In the year 2004, what is the difference between the Expenditure(as % of GDP) in Jamaica and Expenditure(as % of GDP) in United States?
Keep it short and to the point. -1.4. In the year 2005, what is the difference between the Expenditure(as % of GDP) in Belgium and Expenditure(as % of GDP) in Czech Republic?
Offer a terse response. 1.88. In the year 2005, what is the difference between the Expenditure(as % of GDP) of Belgium and Expenditure(as % of GDP) of Jamaica?
Make the answer very short. 1.16. In the year 2005, what is the difference between the Expenditure(as % of GDP) of Belgium and Expenditure(as % of GDP) of United States?
Keep it short and to the point. 0.7. In the year 2005, what is the difference between the Expenditure(as % of GDP) of Czech Republic and Expenditure(as % of GDP) of Jamaica?
Offer a very short reply. -0.72. In the year 2005, what is the difference between the Expenditure(as % of GDP) in Czech Republic and Expenditure(as % of GDP) in United States?
Offer a terse response. -1.18. In the year 2005, what is the difference between the Expenditure(as % of GDP) of Jamaica and Expenditure(as % of GDP) of United States?
Provide a short and direct response. -0.46. In the year 2007, what is the difference between the Expenditure(as % of GDP) in Belgium and Expenditure(as % of GDP) in Czech Republic?
Your answer should be very brief. 1.97. In the year 2007, what is the difference between the Expenditure(as % of GDP) of Belgium and Expenditure(as % of GDP) of Jamaica?
Provide a short and direct response. 0.35. In the year 2007, what is the difference between the Expenditure(as % of GDP) in Belgium and Expenditure(as % of GDP) in United States?
Provide a succinct answer. 0.6. In the year 2007, what is the difference between the Expenditure(as % of GDP) in Czech Republic and Expenditure(as % of GDP) in Jamaica?
Provide a short and direct response. -1.62. In the year 2007, what is the difference between the Expenditure(as % of GDP) of Czech Republic and Expenditure(as % of GDP) of United States?
Ensure brevity in your answer.  -1.37. In the year 2007, what is the difference between the Expenditure(as % of GDP) in Jamaica and Expenditure(as % of GDP) in United States?
Ensure brevity in your answer.  0.24. In the year 2008, what is the difference between the Expenditure(as % of GDP) of Belgium and Expenditure(as % of GDP) of Czech Republic?
Make the answer very short. 2.52. In the year 2008, what is the difference between the Expenditure(as % of GDP) in Belgium and Expenditure(as % of GDP) in Jamaica?
Provide a succinct answer. 0.08. In the year 2008, what is the difference between the Expenditure(as % of GDP) in Belgium and Expenditure(as % of GDP) in United States?
Your answer should be very brief. 0.97. In the year 2008, what is the difference between the Expenditure(as % of GDP) of Czech Republic and Expenditure(as % of GDP) of Jamaica?
Offer a terse response. -2.44. In the year 2008, what is the difference between the Expenditure(as % of GDP) of Czech Republic and Expenditure(as % of GDP) of United States?
Your response must be concise. -1.55. In the year 2008, what is the difference between the Expenditure(as % of GDP) of Jamaica and Expenditure(as % of GDP) of United States?
Make the answer very short. 0.89. In the year 2009, what is the difference between the Expenditure(as % of GDP) of Belgium and Expenditure(as % of GDP) of Czech Republic?
Provide a succinct answer. 2.22. In the year 2009, what is the difference between the Expenditure(as % of GDP) in Belgium and Expenditure(as % of GDP) in Jamaica?
Keep it short and to the point. 0.2. In the year 2009, what is the difference between the Expenditure(as % of GDP) of Belgium and Expenditure(as % of GDP) of United States?
Your response must be concise. 1.15. In the year 2009, what is the difference between the Expenditure(as % of GDP) of Czech Republic and Expenditure(as % of GDP) of Jamaica?
Your answer should be very brief. -2.02. In the year 2009, what is the difference between the Expenditure(as % of GDP) of Czech Republic and Expenditure(as % of GDP) of United States?
Give a very brief answer. -1.07. In the year 2009, what is the difference between the Expenditure(as % of GDP) of Jamaica and Expenditure(as % of GDP) of United States?
Offer a terse response. 0.95. In the year 2010, what is the difference between the Expenditure(as % of GDP) in Belgium and Expenditure(as % of GDP) in Czech Republic?
Keep it short and to the point. 2.32. In the year 2010, what is the difference between the Expenditure(as % of GDP) in Belgium and Expenditure(as % of GDP) in Jamaica?
Keep it short and to the point. 0.03. In the year 2010, what is the difference between the Expenditure(as % of GDP) in Belgium and Expenditure(as % of GDP) in United States?
Offer a terse response. 0.98. In the year 2010, what is the difference between the Expenditure(as % of GDP) in Czech Republic and Expenditure(as % of GDP) in Jamaica?
Ensure brevity in your answer.  -2.29. In the year 2010, what is the difference between the Expenditure(as % of GDP) of Czech Republic and Expenditure(as % of GDP) of United States?
Offer a very short reply. -1.35. In the year 2010, what is the difference between the Expenditure(as % of GDP) in Jamaica and Expenditure(as % of GDP) in United States?
Your answer should be very brief. 0.95. In the year 2011, what is the difference between the Expenditure(as % of GDP) in Belgium and Expenditure(as % of GDP) in Czech Republic?
Give a very brief answer. 2.08. In the year 2011, what is the difference between the Expenditure(as % of GDP) of Belgium and Expenditure(as % of GDP) of Jamaica?
Keep it short and to the point. 0.1. In the year 2011, what is the difference between the Expenditure(as % of GDP) in Belgium and Expenditure(as % of GDP) in United States?
Offer a terse response. 1.14. In the year 2011, what is the difference between the Expenditure(as % of GDP) of Czech Republic and Expenditure(as % of GDP) of Jamaica?
Your answer should be compact. -1.98. In the year 2011, what is the difference between the Expenditure(as % of GDP) of Czech Republic and Expenditure(as % of GDP) of United States?
Provide a succinct answer. -0.94. In the year 2011, what is the difference between the Expenditure(as % of GDP) of Jamaica and Expenditure(as % of GDP) of United States?
Your answer should be very brief. 1.04. What is the ratio of the Expenditure(as % of GDP) in Belgium in 2003 to that in 2004?
Offer a very short reply. 1.01. What is the ratio of the Expenditure(as % of GDP) of Czech Republic in 2003 to that in 2004?
Offer a very short reply. 1.03. What is the ratio of the Expenditure(as % of GDP) of Jamaica in 2003 to that in 2004?
Give a very brief answer. 1.09. What is the ratio of the Expenditure(as % of GDP) of United States in 2003 to that in 2004?
Offer a very short reply. 1.05. What is the ratio of the Expenditure(as % of GDP) in Belgium in 2003 to that in 2005?
Give a very brief answer. 1.02. What is the ratio of the Expenditure(as % of GDP) of Czech Republic in 2003 to that in 2005?
Provide a succinct answer. 1.06. What is the ratio of the Expenditure(as % of GDP) of Jamaica in 2003 to that in 2005?
Offer a terse response. 0.92. What is the ratio of the Expenditure(as % of GDP) in United States in 2003 to that in 2005?
Your response must be concise. 1.1. What is the ratio of the Expenditure(as % of GDP) of Belgium in 2003 to that in 2007?
Your answer should be compact. 1.01. What is the ratio of the Expenditure(as % of GDP) in Czech Republic in 2003 to that in 2007?
Provide a succinct answer. 1.07. What is the ratio of the Expenditure(as % of GDP) of Jamaica in 2003 to that in 2007?
Make the answer very short. 0.78. What is the ratio of the Expenditure(as % of GDP) in United States in 2003 to that in 2007?
Keep it short and to the point. 1.06. What is the ratio of the Expenditure(as % of GDP) in Belgium in 2003 to that in 2008?
Your answer should be compact. 0.94. What is the ratio of the Expenditure(as % of GDP) of Czech Republic in 2003 to that in 2008?
Your response must be concise. 1.11. What is the ratio of the Expenditure(as % of GDP) of Jamaica in 2003 to that in 2008?
Your answer should be very brief. 0.69. What is the ratio of the Expenditure(as % of GDP) in United States in 2003 to that in 2008?
Keep it short and to the point. 1.05. What is the ratio of the Expenditure(as % of GDP) in Belgium in 2003 to that in 2009?
Provide a short and direct response. 0.92. What is the ratio of the Expenditure(as % of GDP) of Jamaica in 2003 to that in 2009?
Give a very brief answer. 0.69. What is the ratio of the Expenditure(as % of GDP) in United States in 2003 to that in 2009?
Make the answer very short. 1.06. What is the ratio of the Expenditure(as % of GDP) in Belgium in 2003 to that in 2010?
Your answer should be compact. 0.92. What is the ratio of the Expenditure(as % of GDP) in Czech Republic in 2003 to that in 2010?
Your answer should be very brief. 1.02. What is the ratio of the Expenditure(as % of GDP) of Jamaica in 2003 to that in 2010?
Provide a short and direct response. 0.67. What is the ratio of the Expenditure(as % of GDP) of United States in 2003 to that in 2010?
Provide a succinct answer. 1.03. What is the ratio of the Expenditure(as % of GDP) in Belgium in 2003 to that in 2011?
Ensure brevity in your answer.  0.93. What is the ratio of the Expenditure(as % of GDP) in Czech Republic in 2003 to that in 2011?
Give a very brief answer. 0.97. What is the ratio of the Expenditure(as % of GDP) of Jamaica in 2003 to that in 2011?
Ensure brevity in your answer.  0.68. What is the ratio of the Expenditure(as % of GDP) in United States in 2003 to that in 2011?
Offer a very short reply. 1.07. What is the ratio of the Expenditure(as % of GDP) of Czech Republic in 2004 to that in 2005?
Your answer should be very brief. 1.03. What is the ratio of the Expenditure(as % of GDP) in Jamaica in 2004 to that in 2005?
Your response must be concise. 0.85. What is the ratio of the Expenditure(as % of GDP) of United States in 2004 to that in 2005?
Provide a short and direct response. 1.05. What is the ratio of the Expenditure(as % of GDP) of Czech Republic in 2004 to that in 2007?
Your response must be concise. 1.04. What is the ratio of the Expenditure(as % of GDP) in Jamaica in 2004 to that in 2007?
Offer a very short reply. 0.71. What is the ratio of the Expenditure(as % of GDP) of Belgium in 2004 to that in 2008?
Your answer should be very brief. 0.93. What is the ratio of the Expenditure(as % of GDP) of Czech Republic in 2004 to that in 2008?
Offer a very short reply. 1.07. What is the ratio of the Expenditure(as % of GDP) of Jamaica in 2004 to that in 2008?
Offer a very short reply. 0.63. What is the ratio of the Expenditure(as % of GDP) of Belgium in 2004 to that in 2009?
Provide a succinct answer. 0.91. What is the ratio of the Expenditure(as % of GDP) of Czech Republic in 2004 to that in 2009?
Offer a very short reply. 0.96. What is the ratio of the Expenditure(as % of GDP) in Jamaica in 2004 to that in 2009?
Ensure brevity in your answer.  0.63. What is the ratio of the Expenditure(as % of GDP) of United States in 2004 to that in 2009?
Your response must be concise. 1.01. What is the ratio of the Expenditure(as % of GDP) of Belgium in 2004 to that in 2010?
Your answer should be compact. 0.91. What is the ratio of the Expenditure(as % of GDP) of Czech Republic in 2004 to that in 2010?
Provide a succinct answer. 0.99. What is the ratio of the Expenditure(as % of GDP) in Jamaica in 2004 to that in 2010?
Provide a succinct answer. 0.61. What is the ratio of the Expenditure(as % of GDP) of United States in 2004 to that in 2010?
Your response must be concise. 0.98. What is the ratio of the Expenditure(as % of GDP) in Belgium in 2004 to that in 2011?
Provide a short and direct response. 0.91. What is the ratio of the Expenditure(as % of GDP) in Czech Republic in 2004 to that in 2011?
Provide a succinct answer. 0.94. What is the ratio of the Expenditure(as % of GDP) in Jamaica in 2004 to that in 2011?
Ensure brevity in your answer.  0.62. What is the ratio of the Expenditure(as % of GDP) of United States in 2004 to that in 2011?
Offer a terse response. 1.02. What is the ratio of the Expenditure(as % of GDP) in Belgium in 2005 to that in 2007?
Provide a short and direct response. 0.99. What is the ratio of the Expenditure(as % of GDP) of Czech Republic in 2005 to that in 2007?
Your answer should be compact. 1.01. What is the ratio of the Expenditure(as % of GDP) of Jamaica in 2005 to that in 2007?
Keep it short and to the point. 0.84. What is the ratio of the Expenditure(as % of GDP) of United States in 2005 to that in 2007?
Provide a short and direct response. 0.97. What is the ratio of the Expenditure(as % of GDP) of Belgium in 2005 to that in 2008?
Give a very brief answer. 0.92. What is the ratio of the Expenditure(as % of GDP) in Czech Republic in 2005 to that in 2008?
Offer a terse response. 1.04. What is the ratio of the Expenditure(as % of GDP) of Jamaica in 2005 to that in 2008?
Provide a short and direct response. 0.75. What is the ratio of the Expenditure(as % of GDP) in United States in 2005 to that in 2008?
Keep it short and to the point. 0.96. What is the ratio of the Expenditure(as % of GDP) of Belgium in 2005 to that in 2009?
Ensure brevity in your answer.  0.9. What is the ratio of the Expenditure(as % of GDP) of Czech Republic in 2005 to that in 2009?
Provide a short and direct response. 0.93. What is the ratio of the Expenditure(as % of GDP) of Jamaica in 2005 to that in 2009?
Offer a very short reply. 0.74. What is the ratio of the Expenditure(as % of GDP) of United States in 2005 to that in 2009?
Your answer should be compact. 0.97. What is the ratio of the Expenditure(as % of GDP) in Belgium in 2005 to that in 2010?
Your answer should be very brief. 0.9. What is the ratio of the Expenditure(as % of GDP) in Czech Republic in 2005 to that in 2010?
Offer a very short reply. 0.96. What is the ratio of the Expenditure(as % of GDP) of Jamaica in 2005 to that in 2010?
Provide a short and direct response. 0.72. What is the ratio of the Expenditure(as % of GDP) in United States in 2005 to that in 2010?
Keep it short and to the point. 0.94. What is the ratio of the Expenditure(as % of GDP) of Belgium in 2005 to that in 2011?
Make the answer very short. 0.91. What is the ratio of the Expenditure(as % of GDP) of Czech Republic in 2005 to that in 2011?
Your response must be concise. 0.91. What is the ratio of the Expenditure(as % of GDP) in Jamaica in 2005 to that in 2011?
Provide a short and direct response. 0.74. What is the ratio of the Expenditure(as % of GDP) in United States in 2005 to that in 2011?
Make the answer very short. 0.97. What is the ratio of the Expenditure(as % of GDP) in Belgium in 2007 to that in 2008?
Provide a short and direct response. 0.93. What is the ratio of the Expenditure(as % of GDP) of Czech Republic in 2007 to that in 2008?
Offer a very short reply. 1.03. What is the ratio of the Expenditure(as % of GDP) in Jamaica in 2007 to that in 2008?
Make the answer very short. 0.89. What is the ratio of the Expenditure(as % of GDP) of United States in 2007 to that in 2008?
Offer a terse response. 0.99. What is the ratio of the Expenditure(as % of GDP) of Belgium in 2007 to that in 2009?
Provide a short and direct response. 0.91. What is the ratio of the Expenditure(as % of GDP) of Czech Republic in 2007 to that in 2009?
Keep it short and to the point. 0.93. What is the ratio of the Expenditure(as % of GDP) in Jamaica in 2007 to that in 2009?
Offer a terse response. 0.89. What is the ratio of the Expenditure(as % of GDP) of United States in 2007 to that in 2009?
Ensure brevity in your answer.  1. What is the ratio of the Expenditure(as % of GDP) of Belgium in 2007 to that in 2010?
Make the answer very short. 0.91. What is the ratio of the Expenditure(as % of GDP) of Czech Republic in 2007 to that in 2010?
Make the answer very short. 0.95. What is the ratio of the Expenditure(as % of GDP) in Jamaica in 2007 to that in 2010?
Provide a short and direct response. 0.86. What is the ratio of the Expenditure(as % of GDP) in Belgium in 2007 to that in 2011?
Offer a very short reply. 0.92. What is the ratio of the Expenditure(as % of GDP) of Czech Republic in 2007 to that in 2011?
Your response must be concise. 0.9. What is the ratio of the Expenditure(as % of GDP) in Jamaica in 2007 to that in 2011?
Your answer should be compact. 0.88. What is the ratio of the Expenditure(as % of GDP) of Belgium in 2008 to that in 2009?
Offer a terse response. 0.98. What is the ratio of the Expenditure(as % of GDP) in Czech Republic in 2008 to that in 2009?
Keep it short and to the point. 0.9. What is the ratio of the Expenditure(as % of GDP) of United States in 2008 to that in 2009?
Offer a terse response. 1.01. What is the ratio of the Expenditure(as % of GDP) in Belgium in 2008 to that in 2010?
Your response must be concise. 0.98. What is the ratio of the Expenditure(as % of GDP) of Czech Republic in 2008 to that in 2010?
Provide a succinct answer. 0.92. What is the ratio of the Expenditure(as % of GDP) in Jamaica in 2008 to that in 2010?
Your answer should be very brief. 0.97. What is the ratio of the Expenditure(as % of GDP) of United States in 2008 to that in 2010?
Provide a short and direct response. 0.98. What is the ratio of the Expenditure(as % of GDP) in Belgium in 2008 to that in 2011?
Offer a very short reply. 0.99. What is the ratio of the Expenditure(as % of GDP) of Czech Republic in 2008 to that in 2011?
Your response must be concise. 0.88. What is the ratio of the Expenditure(as % of GDP) of Jamaica in 2008 to that in 2011?
Ensure brevity in your answer.  0.99. What is the ratio of the Expenditure(as % of GDP) in United States in 2008 to that in 2011?
Make the answer very short. 1.02. What is the ratio of the Expenditure(as % of GDP) of Belgium in 2009 to that in 2010?
Your answer should be very brief. 1. What is the ratio of the Expenditure(as % of GDP) in Czech Republic in 2009 to that in 2010?
Give a very brief answer. 1.03. What is the ratio of the Expenditure(as % of GDP) of Jamaica in 2009 to that in 2010?
Offer a very short reply. 0.97. What is the ratio of the Expenditure(as % of GDP) in United States in 2009 to that in 2010?
Give a very brief answer. 0.97. What is the ratio of the Expenditure(as % of GDP) of Belgium in 2009 to that in 2011?
Your response must be concise. 1.01. What is the ratio of the Expenditure(as % of GDP) of Czech Republic in 2009 to that in 2011?
Offer a very short reply. 0.98. What is the ratio of the Expenditure(as % of GDP) in Jamaica in 2009 to that in 2011?
Offer a terse response. 0.99. What is the ratio of the Expenditure(as % of GDP) in United States in 2009 to that in 2011?
Make the answer very short. 1. What is the ratio of the Expenditure(as % of GDP) in Czech Republic in 2010 to that in 2011?
Provide a short and direct response. 0.95. What is the ratio of the Expenditure(as % of GDP) in United States in 2010 to that in 2011?
Your answer should be compact. 1.04. What is the difference between the highest and the second highest Expenditure(as % of GDP) in Belgium?
Keep it short and to the point. 0. What is the difference between the highest and the second highest Expenditure(as % of GDP) in Czech Republic?
Ensure brevity in your answer.  0.1. What is the difference between the highest and the second highest Expenditure(as % of GDP) in Jamaica?
Offer a terse response. 0.11. What is the difference between the highest and the second highest Expenditure(as % of GDP) of United States?
Ensure brevity in your answer.  0.15. What is the difference between the highest and the lowest Expenditure(as % of GDP) of Belgium?
Keep it short and to the point. 0.62. What is the difference between the highest and the lowest Expenditure(as % of GDP) of Czech Republic?
Your response must be concise. 0.53. What is the difference between the highest and the lowest Expenditure(as % of GDP) in Jamaica?
Offer a terse response. 2.46. What is the difference between the highest and the lowest Expenditure(as % of GDP) in United States?
Give a very brief answer. 0.49. 